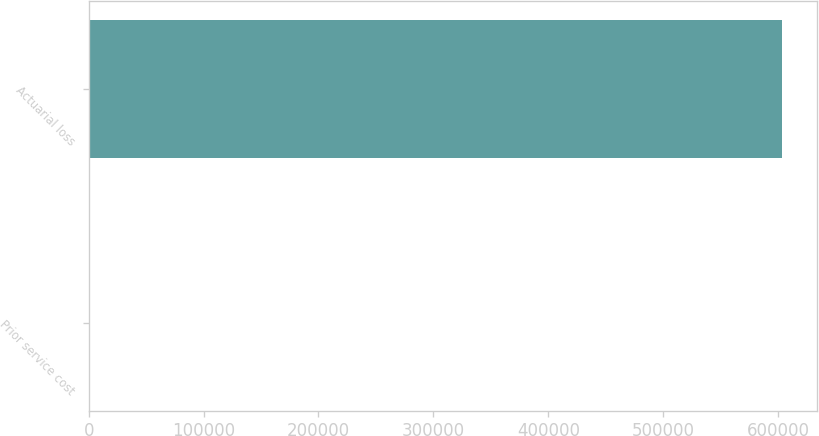Convert chart to OTSL. <chart><loc_0><loc_0><loc_500><loc_500><bar_chart><fcel>Prior service cost<fcel>Actuarial loss<nl><fcel>216<fcel>603394<nl></chart> 